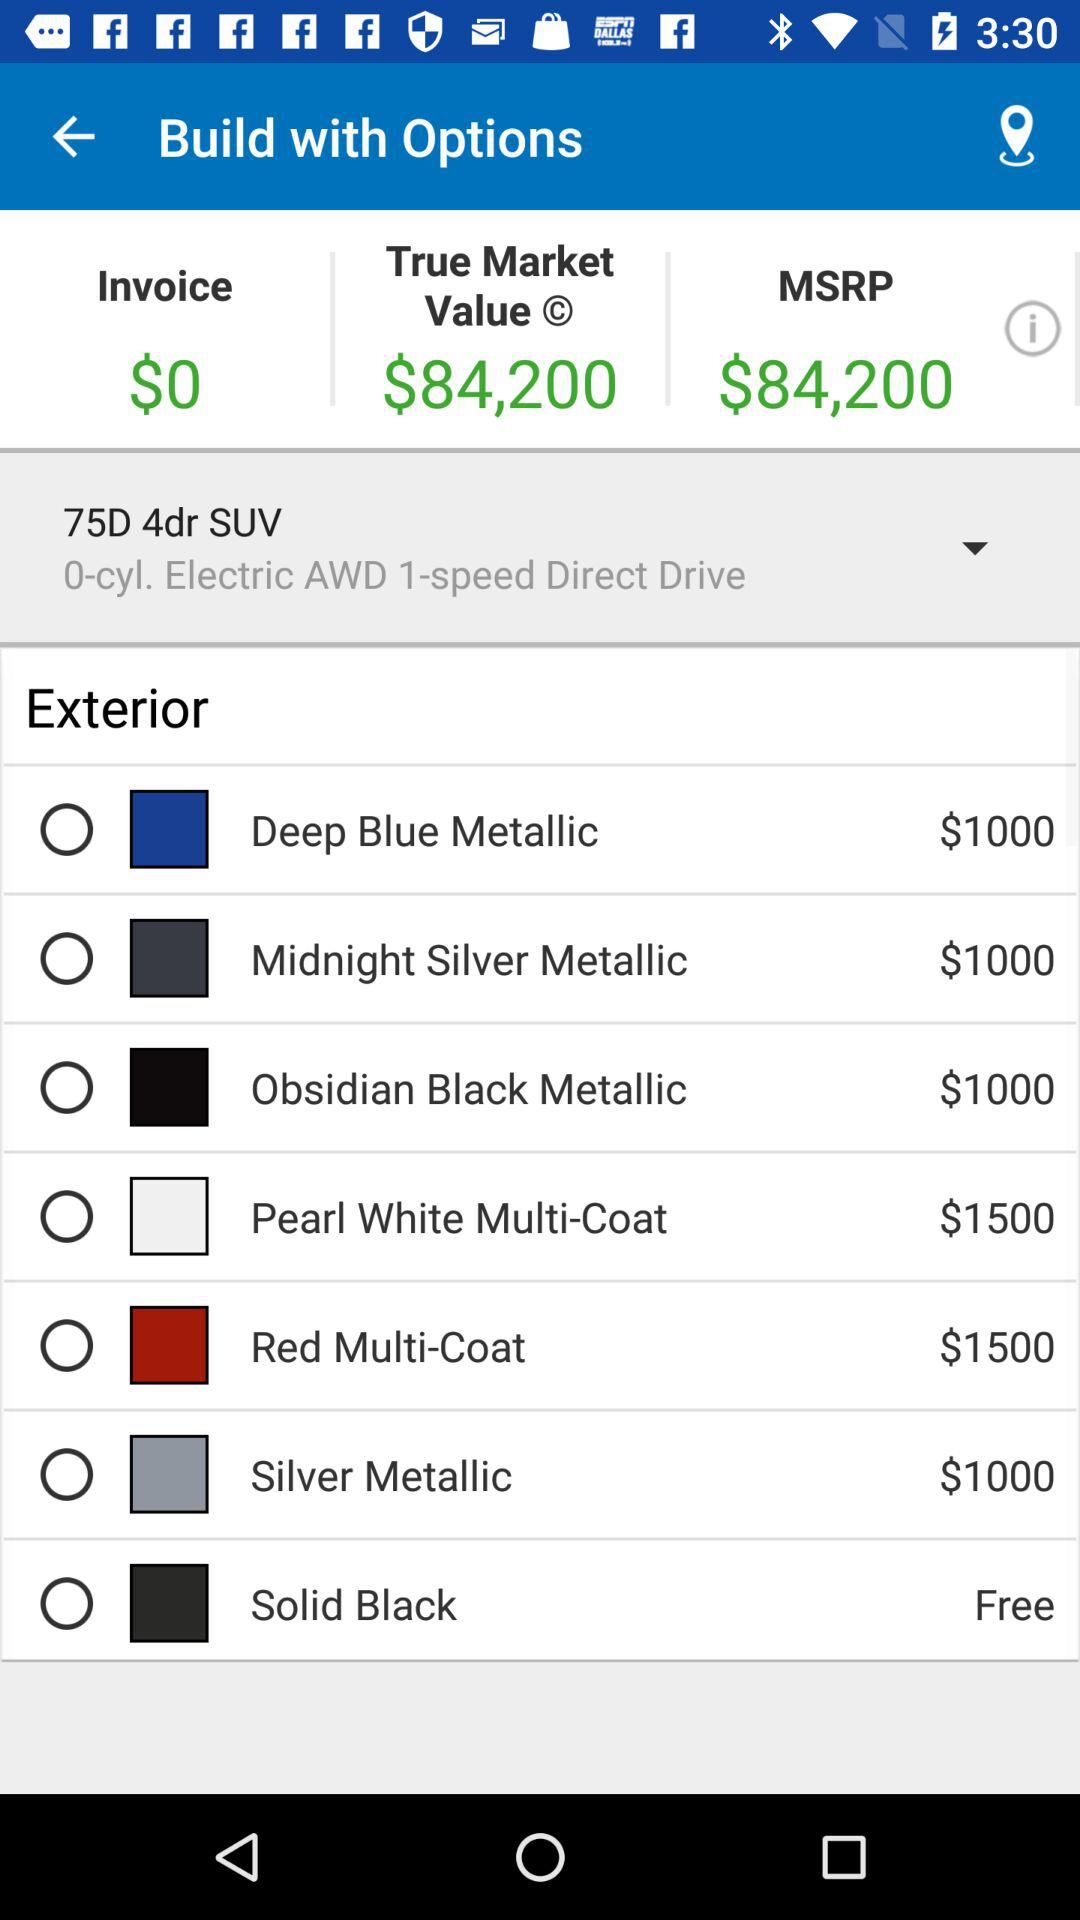What is the price of the "Red Multi-Coat" in "Exterior"? The price of the "Red Multi-Coat" in "Exterior" is $1500. 